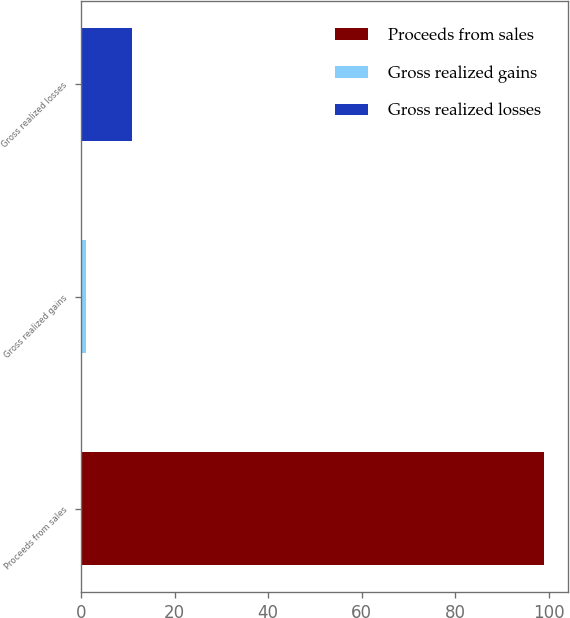Convert chart. <chart><loc_0><loc_0><loc_500><loc_500><bar_chart><fcel>Proceeds from sales<fcel>Gross realized gains<fcel>Gross realized losses<nl><fcel>99<fcel>1<fcel>10.8<nl></chart> 